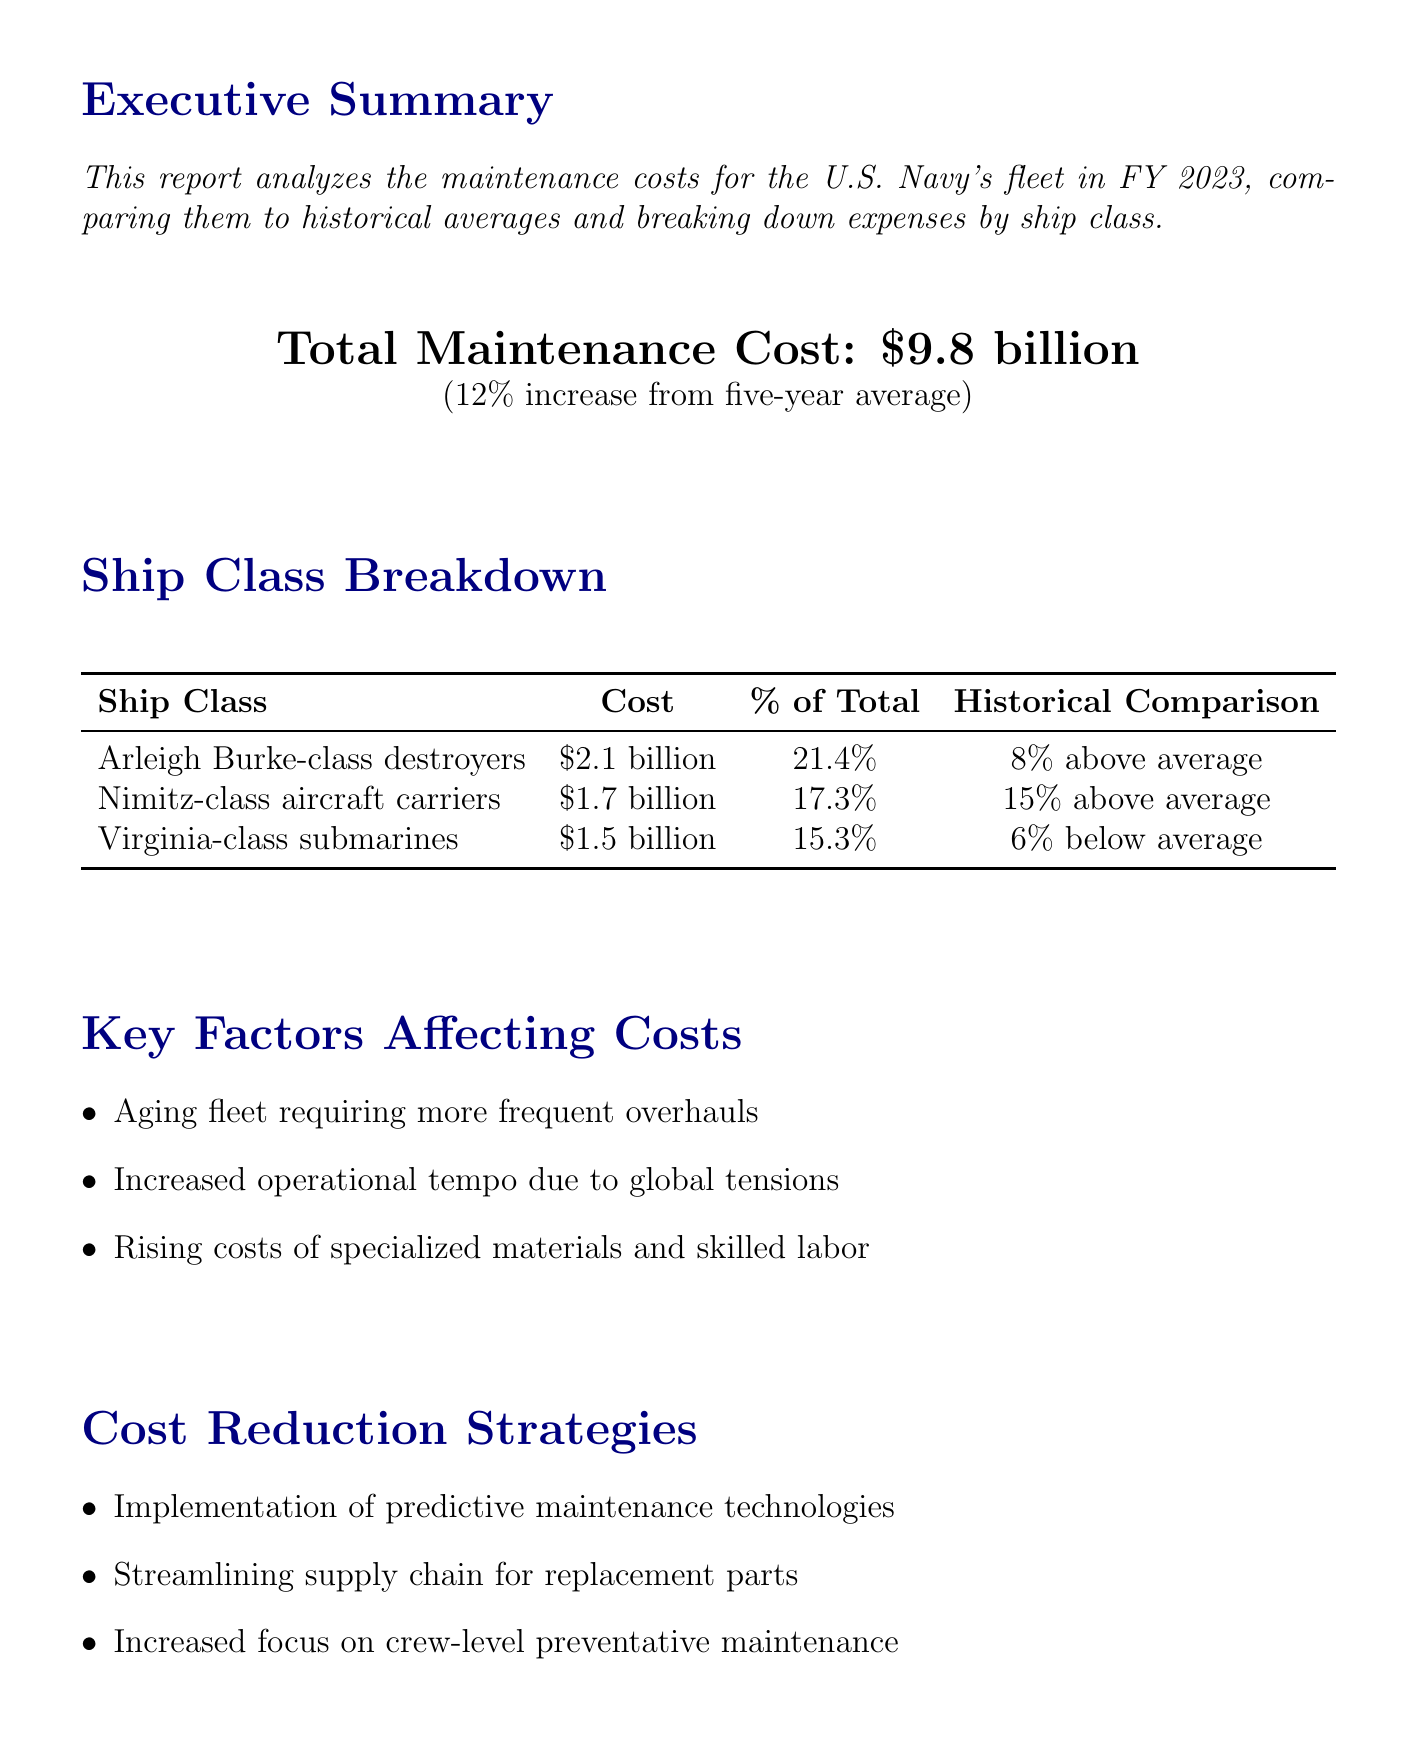what is the total maintenance cost for FY 2023? The total maintenance cost for FY 2023 is explicitly stated in the report as $9.8 billion.
Answer: $9.8 billion how much have the maintenance costs increased compared to the five-year average? The report indicates that the maintenance costs have seen a 12% increase from the five-year average.
Answer: 12% what is the maintenance cost for Arleigh Burke-class destroyers? The document breaks down the maintenance costs by ship class, indicating that Arleigh Burke-class destroyers cost $2.1 billion.
Answer: $2.1 billion which ship class has a cost below its five-year average? The report mentions Virginia-class submarines which have a cost that is 6% below the five-year average.
Answer: Virginia-class submarines what key factor is mentioned that affects maintenance costs? The report lists several key factors affecting costs, one of which is "Aging fleet requiring more frequent overhauls".
Answer: Aging fleet requiring more frequent overhauls what is the projected maintenance cost increase for FY 2024? The future outlook section of the report states a projected 5% increase in maintenance costs for FY 2024.
Answer: 5% what was the percentage of total cost for Nimitz-class aircraft carriers? The report states the Nimitz-class aircraft carriers account for 17.3% of the total maintenance cost.
Answer: 17.3% what strategy is mentioned for cost reduction? The report includes multiple strategies for cost reduction, one of which is "Implementation of predictive maintenance technologies".
Answer: Implementation of predictive maintenance technologies how does the current maintenance cost compare to historical spending? The historical context indicates that current maintenance costs remain lower as a percentage of total naval spending compared to certain historical periods.
Answer: Lower than post-World War II and Vietnam War eras 